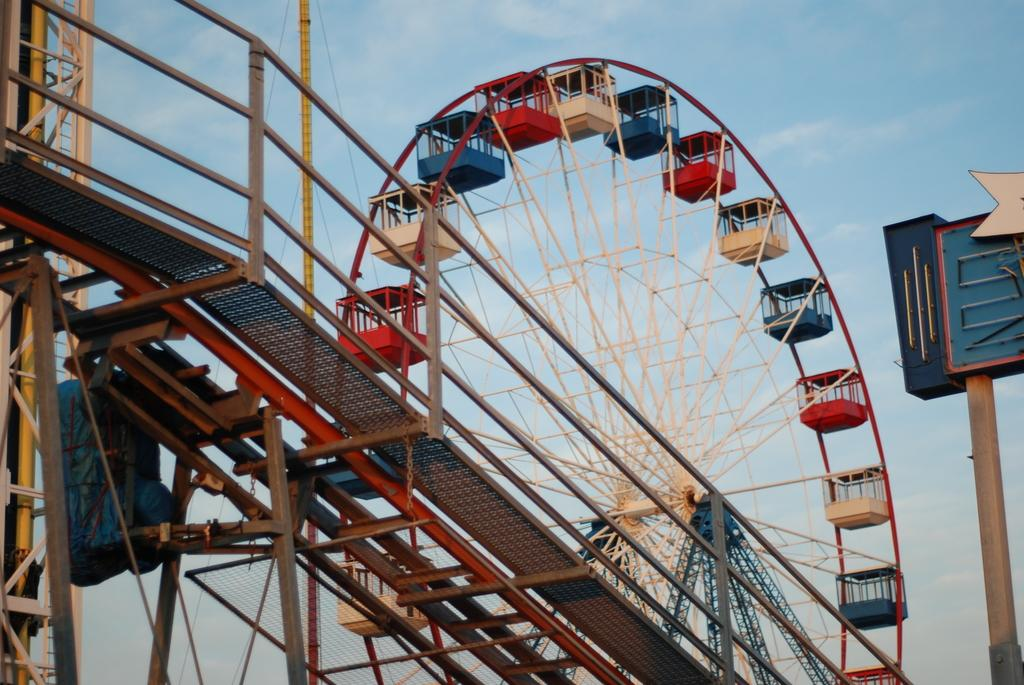What is the main subject of the image? There is a giant wheel in the image. Are there any other objects or features in the image besides the giant wheel? Yes, there are other objects in the image. What can be seen in the background of the image? The sky is visible in the background of the image. How many scarves are hanging from the giant wheel in the image? There are no scarves present in the image. What type of things can be seen hanging from the giant wheel in the image? The facts provided do not specify any objects hanging from the giant wheel, so we cannot answer this question. 